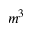<formula> <loc_0><loc_0><loc_500><loc_500>m ^ { 3 }</formula> 